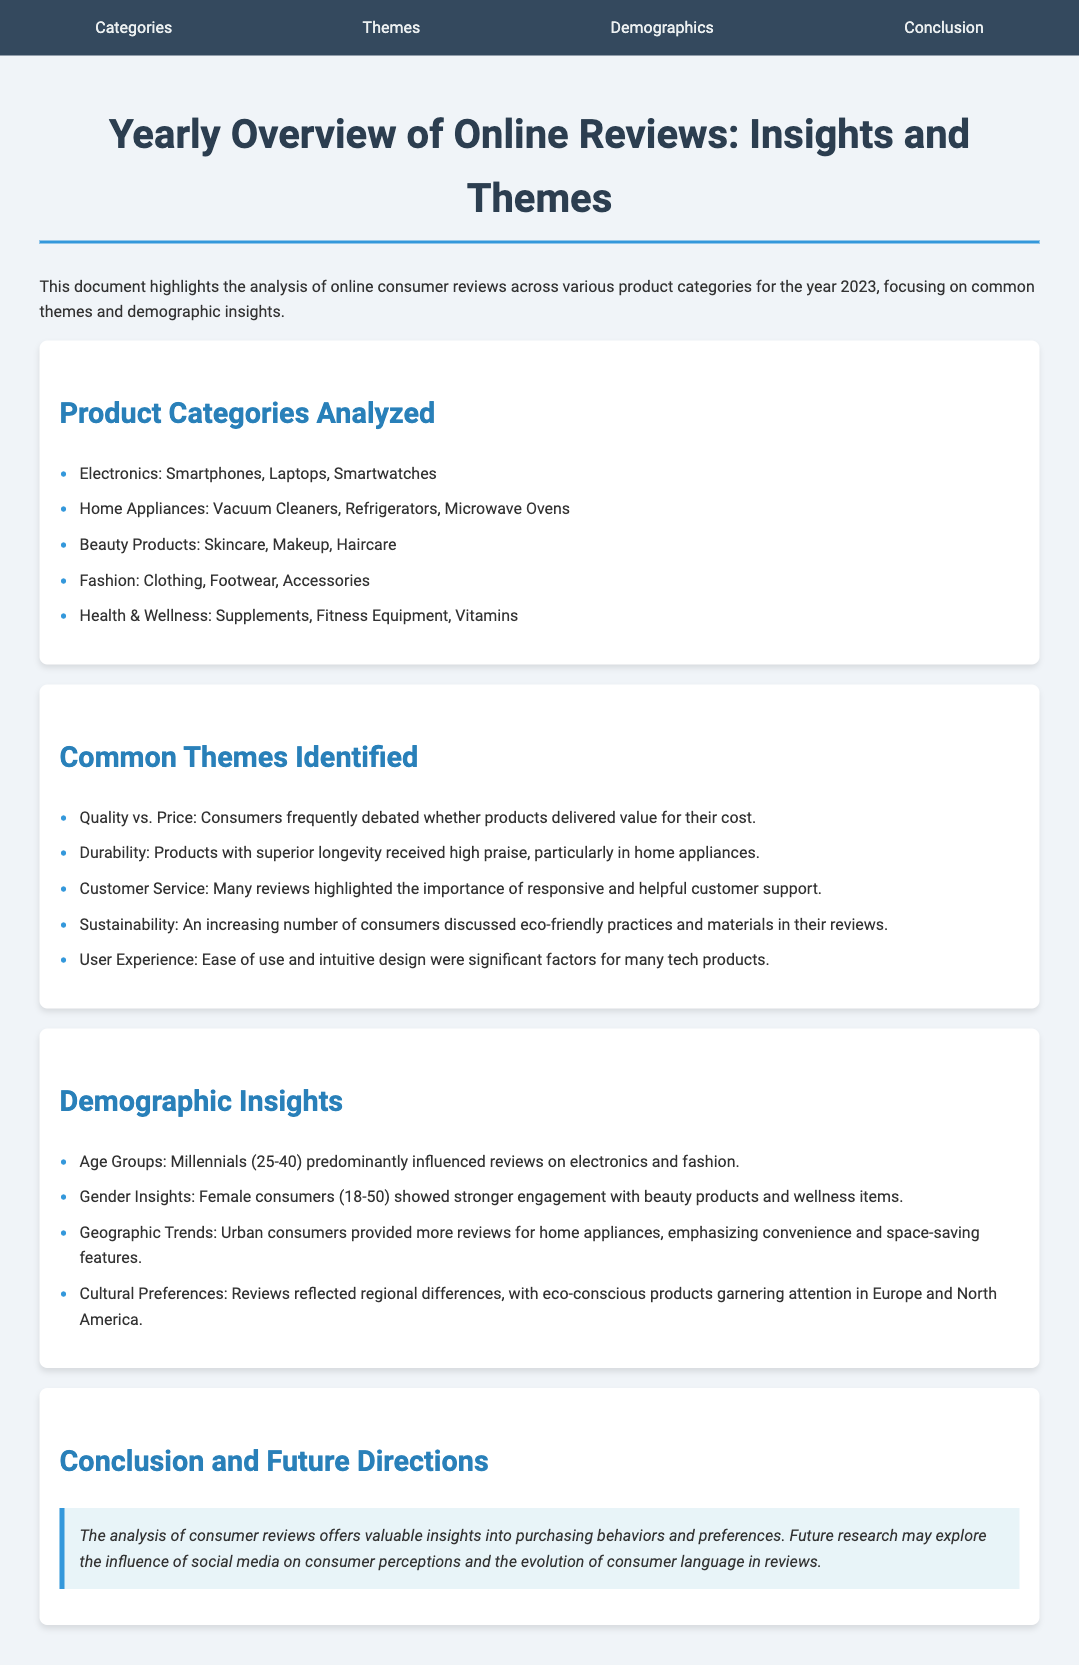What are the product categories analyzed? The categories listed provide a summary of the types of products reviewed, including electronics, home appliances, beauty products, fashion, and health & wellness.
Answer: Electronics, Home Appliances, Beauty Products, Fashion, Health & Wellness What common theme discusses the comparison of value? The theme highlights consumer discussions regarding the relationship between product quality and its price, indicating a significant consumer concern.
Answer: Quality vs. Price Which age group predominantly influenced reviews on electronics and fashion? The document specifies that Millennials, aged between 25 to 40, played a significant role in reviewing these categories.
Answer: Millennials What demographic showed stronger engagement with beauty products? The identified demographic group that had a greater interest in beauty products is detailed in the document.
Answer: Female consumers What aspect of customer experience is frequently highlighted in reviews? This theme focuses on the essential role of customer service in consumer satisfaction, indicating its critical importance.
Answer: Customer Service How are urban consumers characterized in their review behavior? The document notes that urban consumers tend to focus more on convenience and space-saving features, reflecting their review trends.
Answer: Convenience and space-saving features What conclusion does the document imply about consumer behavior analysis? The analysis suggests a direction for future research themes, particularly highlighting the role of social media.
Answer: Influence of social media Which product category received high praise for durability? The document indicates that durability received particular emphasis and appreciation from consumer reviews, especially in a specific category.
Answer: Home appliances In which regions are eco-conscious products particularly noted? The document identified specific regions where consumer interest in eco-friendly products is noticeably higher.
Answer: Europe and North America 